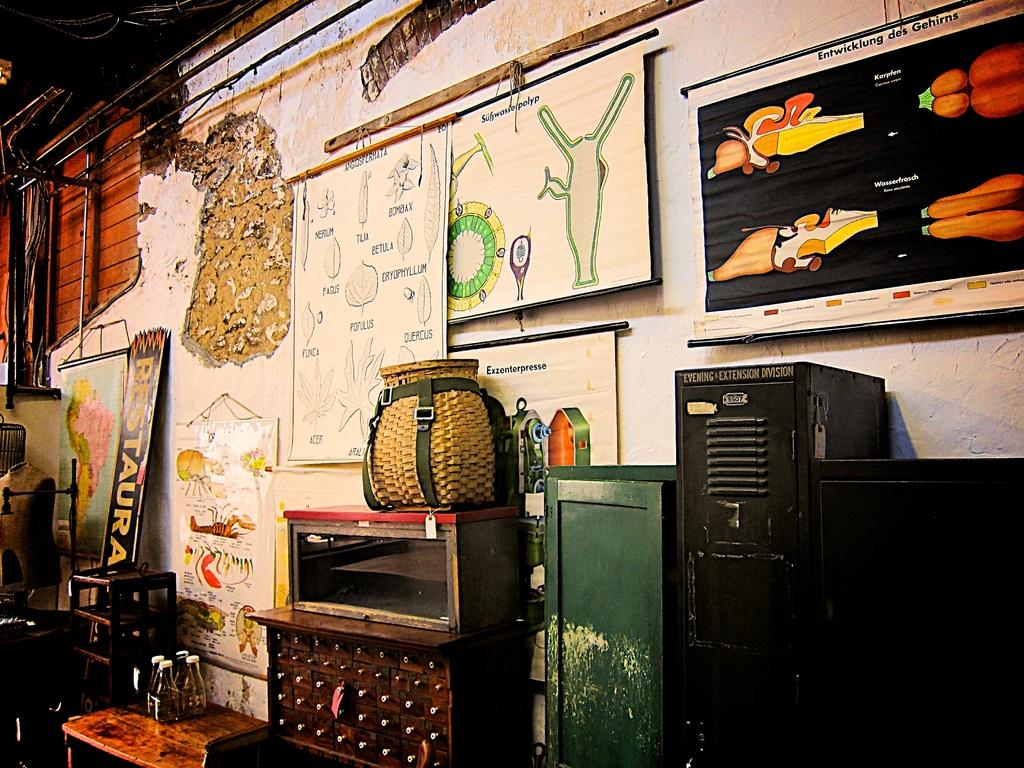Where is the bag located in the image? The bag is in a cupboard in the image. What is attached to the wall in the image? There is a pictorial board attached to a wall in the image. What can be seen running along the walls in the image? Pipes are visible in the image. What type of containers can be seen in the image? There are bottles in the image. Are there any other storage units in the image? Yes, there is another cupboard in the image. What type of thread is being used to decorate the bedroom in the image? There is no bedroom present in the image, and therefore no thread for decoration. What emotion is being expressed by the objects in the image? The objects in the image do not express emotions; they are inanimate. 